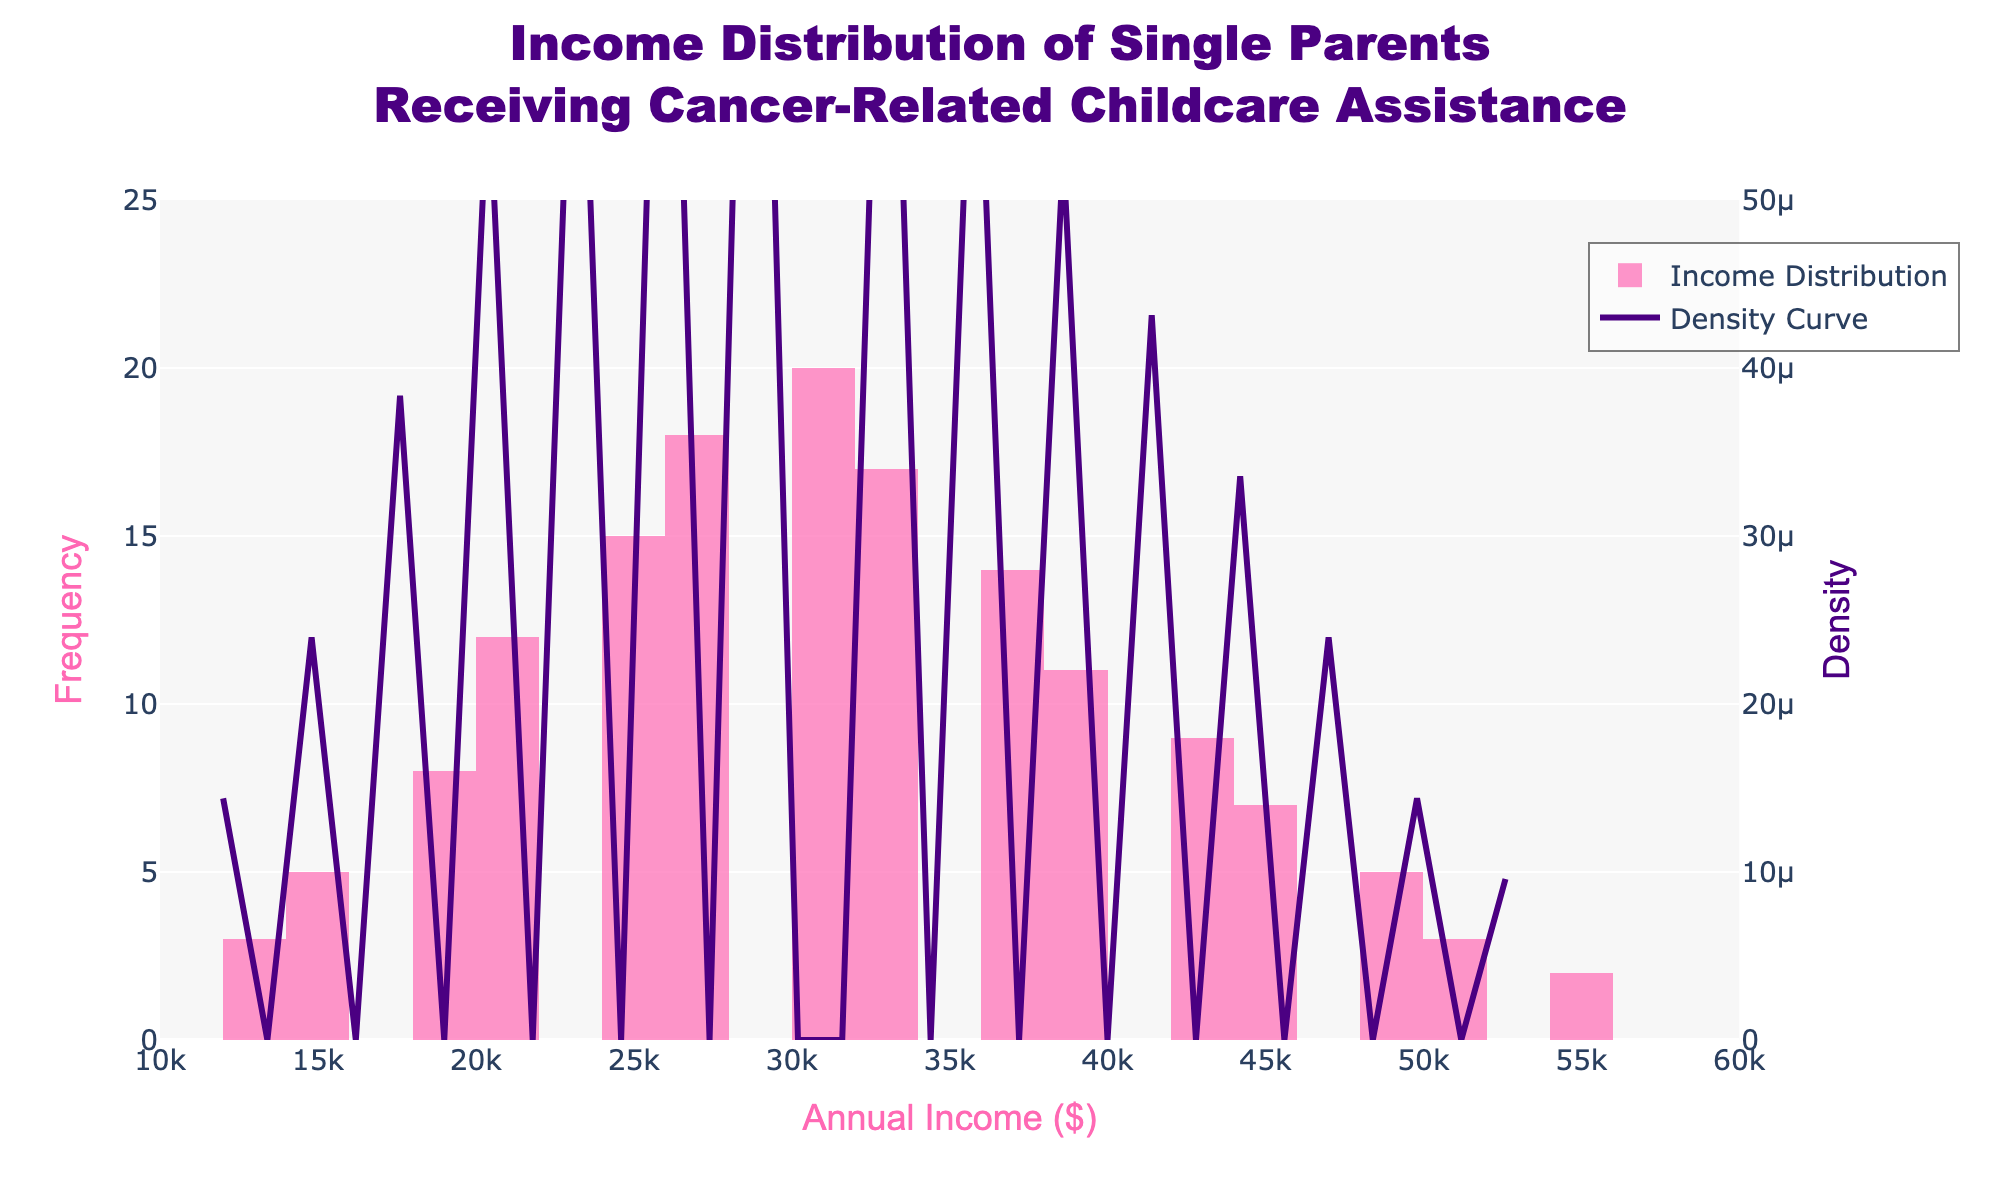What's the title of the plot? The title of a plot is typically found at the top center of the figure. It summarizes the main topic or data being represented. In this case, it reads "Income Distribution of Single Parents Receiving Cancer-Related Childcare Assistance".
Answer: Income Distribution of Single Parents Receiving Cancer-Related Childcare Assistance What do the x-axis and y-axis represent respectively? The x-axis and y-axis titles provide information about what each axis represents. Here, the x-axis is labeled "Annual Income ($)" and the y-axis on the left is labeled "Frequency".
Answer: x-axis: Annual Income ($), y-axis: Frequency At what income level does the frequency peak? To identify the peak frequency, observe the tallest bar in the histogram. The tallest bar appears around the $30,000 income level.
Answer: Around $30,000 How many parents fall within the $30,000 annual income bracket? Look at the height of the bar around the $30,000 mark on the histogram, and this indicates the frequency of that income level, which is 20.
Answer: 20 Which color represents the density curve? Identify the color of the density curve by observing its line color on the figure. The density curve is represented by a purple line.
Answer: Purple What is the number of single parents receiving financial assistance earning between $15,000 and $45,000 annually? To answer this, sum the frequencies of the bars representing income levels from $15,000 to $45,000. Adding these frequencies: 5 + 8 + 12 + 15 + 18 + 20 + 17 + 14 + 11 + 9 + 7 = 136
Answer: 136 Is the income distribution for single parents receiving cancer-related childcare assistance positively or negatively skewed? Observe the histogram and density curve's shape. If most data concentration is to the left and the tail extends to the right, it suggests a positive skew.
Answer: Positively skewed Between which two income levels does the density curve start to decrease significantly? Focus on the point where the density curve begins to decline sharply. This change occurs between the income levels $30,000 and $45,000.
Answer: Between $30,000 and $45,000 What is the approximate density value at the $30,000 income level? Find where the $30,000 income aligns on the density curve and estimate the y-axis value (density). The y-axis for density shows it around 0.000012.
Answer: Around 0.000012 